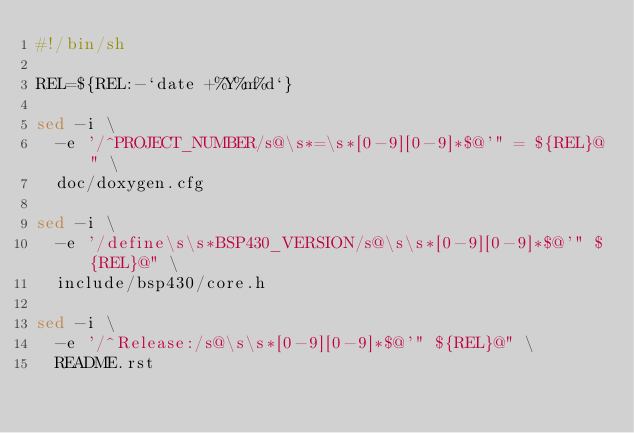<code> <loc_0><loc_0><loc_500><loc_500><_Bash_>#!/bin/sh

REL=${REL:-`date +%Y%m%d`}

sed -i \
  -e '/^PROJECT_NUMBER/s@\s*=\s*[0-9][0-9]*$@'" = ${REL}@" \
  doc/doxygen.cfg

sed -i \
  -e '/define\s\s*BSP430_VERSION/s@\s\s*[0-9][0-9]*$@'" ${REL}@" \
  include/bsp430/core.h

sed -i \
  -e '/^Release:/s@\s\s*[0-9][0-9]*$@'" ${REL}@" \
  README.rst
</code> 